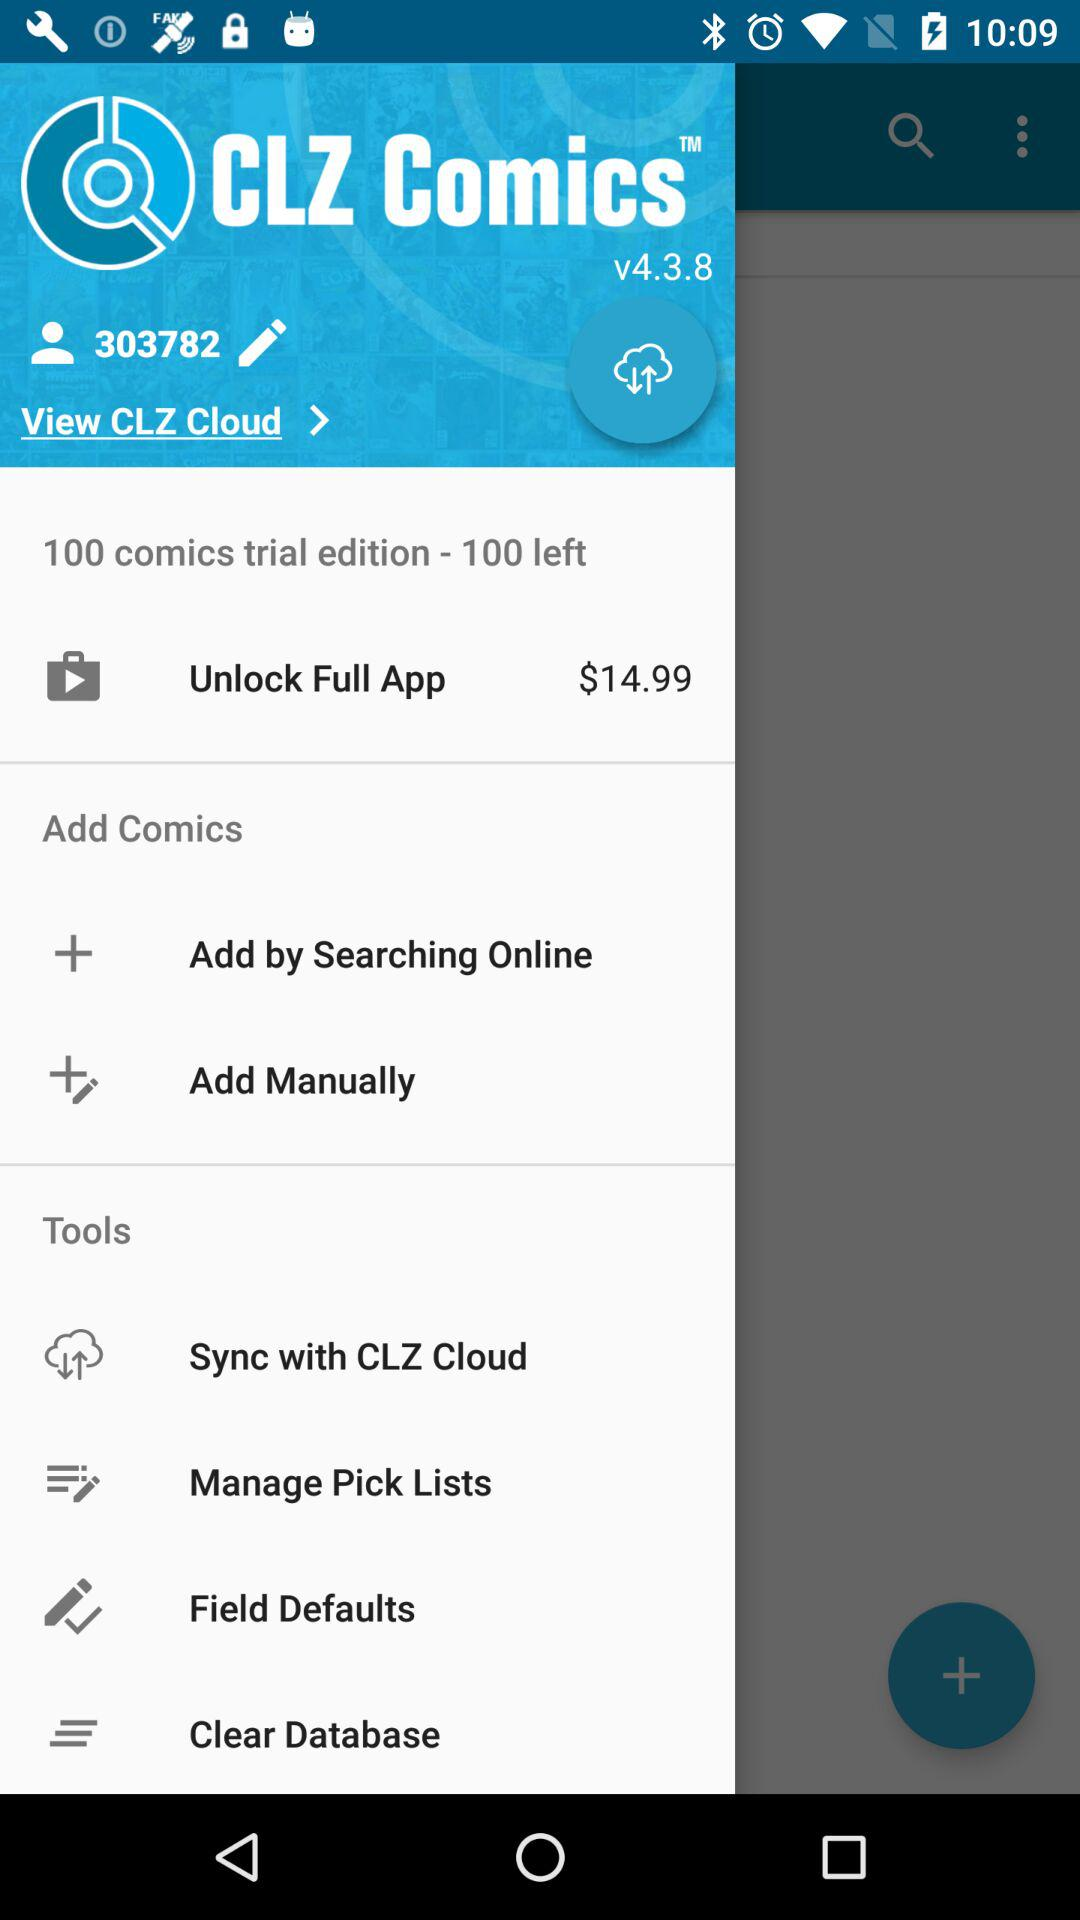What is the user ID? The user ID is 303782. 